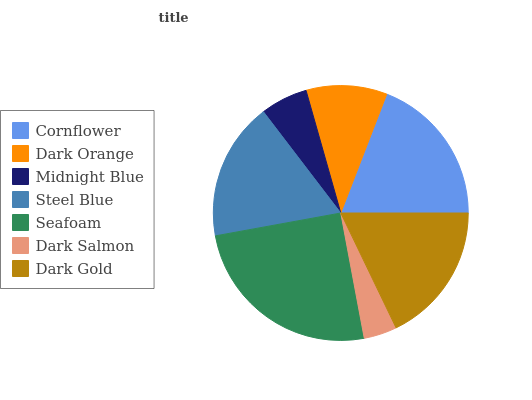Is Dark Salmon the minimum?
Answer yes or no. Yes. Is Seafoam the maximum?
Answer yes or no. Yes. Is Dark Orange the minimum?
Answer yes or no. No. Is Dark Orange the maximum?
Answer yes or no. No. Is Cornflower greater than Dark Orange?
Answer yes or no. Yes. Is Dark Orange less than Cornflower?
Answer yes or no. Yes. Is Dark Orange greater than Cornflower?
Answer yes or no. No. Is Cornflower less than Dark Orange?
Answer yes or no. No. Is Steel Blue the high median?
Answer yes or no. Yes. Is Steel Blue the low median?
Answer yes or no. Yes. Is Cornflower the high median?
Answer yes or no. No. Is Midnight Blue the low median?
Answer yes or no. No. 